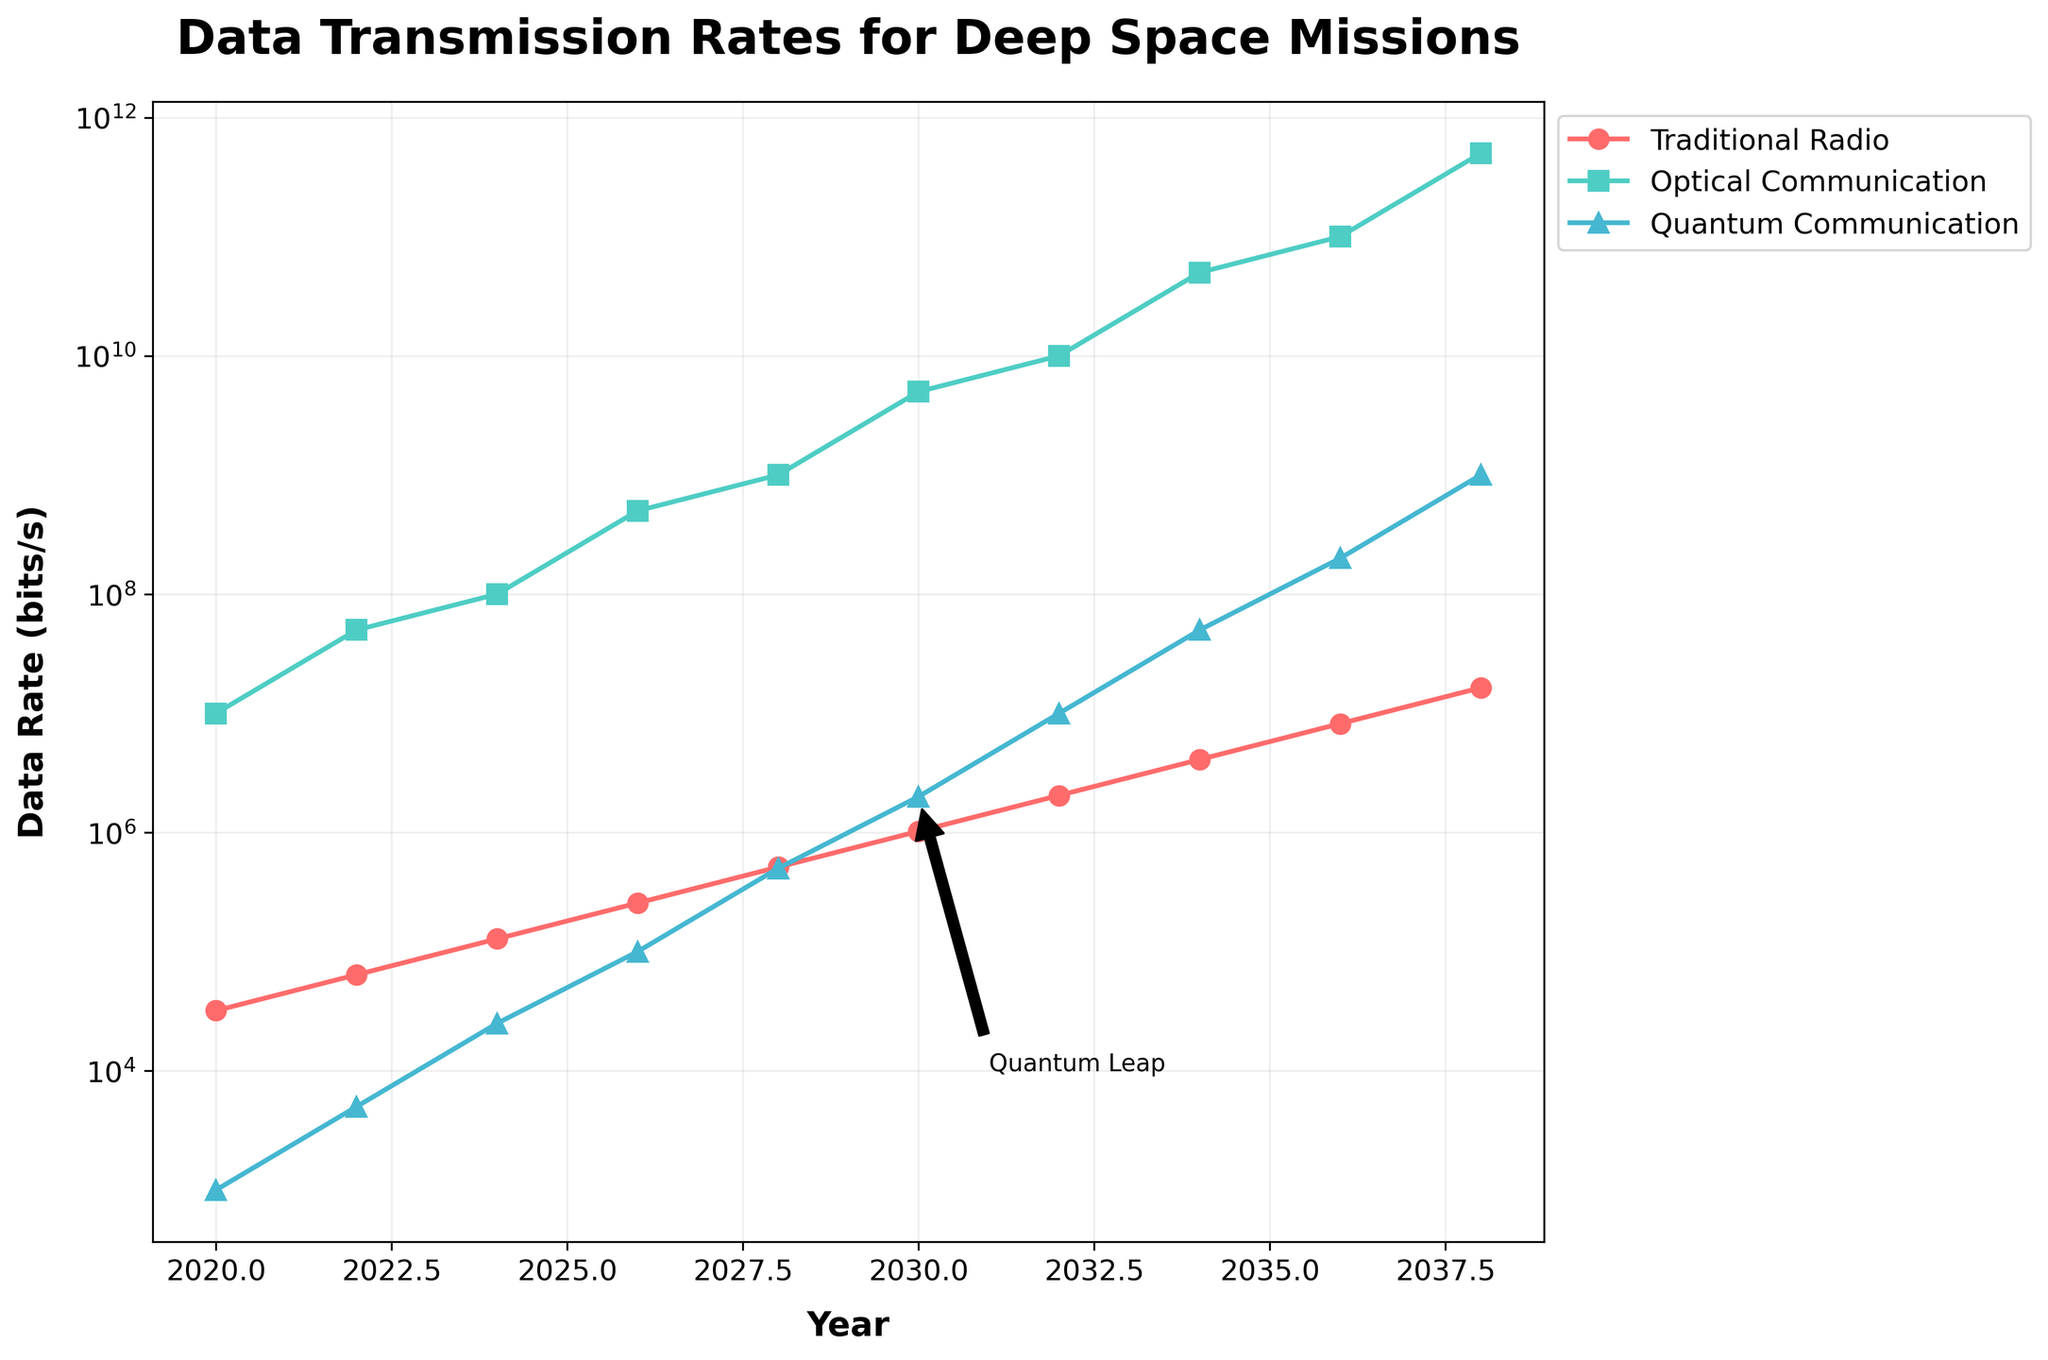What is the data transmission rate for Optical Communication in 2024? Locate the Optical Communication data transmission rate point corresponding to the year 2024 on the graph (green line with square markers) and read its value.
Answer: 100,000,000 bits/s How much did the data transmission rate for Traditional Radio increase from 2020 to 2030? Subtract the Traditional Radio data transmission rate in 2020 from the rate in 2030: 1,024,000 bits/s - 32,000 bits/s = 992,000 bits/s increase.
Answer: 992,000 bits/s By how many orders of magnitude does Quantum Communication improve from 2020 to 2038? Calculate the logarithm (base 10) of the data transmission rate ratio between 2038 and 2020 for Quantum Communication: log10(1,000,000,000 / 1,000) = log10(1,000,000) = 6 orders of magnitude.
Answer: 6 In which year did Optical Communication surpass the 50,000,000 bits/s mark? Examine the Optical Communication data points and find the first year where the rate exceeds 50,000,000 bits/s, which is in 2022 (50,000,000 bits/s).
Answer: 2022 Compare the data rates between Traditional Radio and Quantum Communication in 2036. Which has a higher rate? Identify the transmission rates of Traditional Radio and Quantum Communication in 2036 from the graph and compare them: Traditional Radio (8,192,000 bits/s) < Quantum Communication (200,000,000 bits/s).
Answer: Quantum Communication Between 2028 and 2030, which communication method shows the most substantial improvement in data transmission rate? Analyze the slopes of the lines for each communication method between 2028 and 2030. Optical Communication has a sharper slope from 1,000,000,000 bits/s to 5,000,000,000 bits/s, compared to the smaller differences for Traditional Radio and Quantum Communication.
Answer: Optical Communication What visual indication highlights a significant milestone in Quantum Communication around 2030? Look for any visual annotations on the graph around the 2030 mark; an arrow labeled "Quantum Leap" points out the key milestone for Quantum Communication at 2,000,000 bits/s.
Answer: Quantum Leap annotation How does the data transmission rate for Traditional Radio in 2038 compare to Optical Communication in 2020? Compare the data transmission rates directly from the graph. Traditional Radio in 2038 is at 16,384,000 bits/s, while Optical Communication in 2020 is at 10,000,000 bits/s; Traditional Radio in 2038 has the higher rate.
Answer: Traditional Radio in 2038 What trend is evident in Quantum Communication's data rate progression from 2020 to 2038? Observe the trendline of Quantum Communication’s data rate over the years; it follows an exponential growth pattern, gradually increasing its transmission rates.
Answer: Exponential growth 